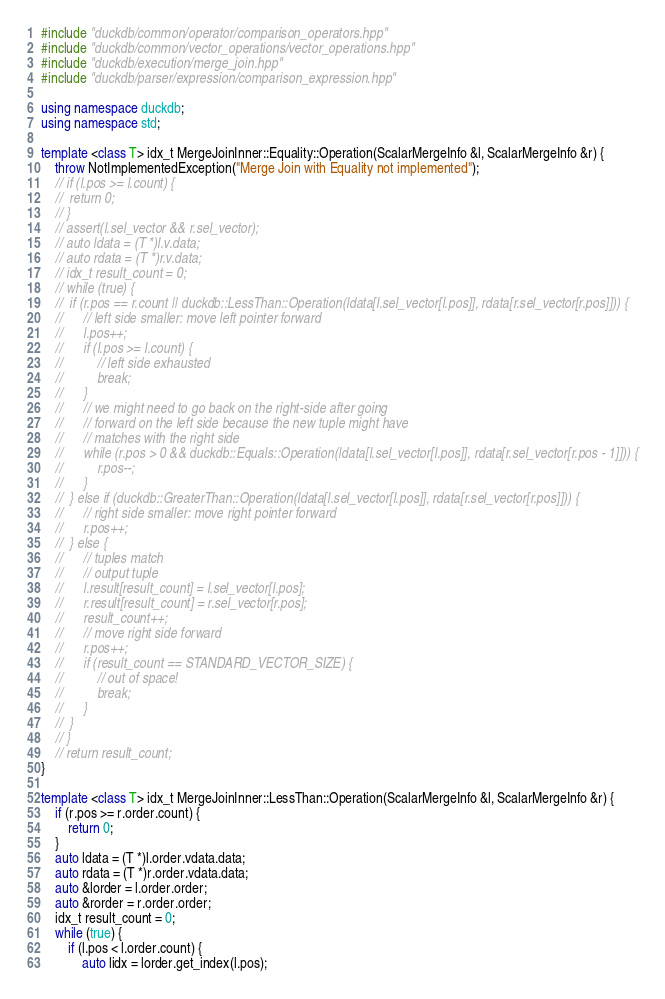Convert code to text. <code><loc_0><loc_0><loc_500><loc_500><_C++_>#include "duckdb/common/operator/comparison_operators.hpp"
#include "duckdb/common/vector_operations/vector_operations.hpp"
#include "duckdb/execution/merge_join.hpp"
#include "duckdb/parser/expression/comparison_expression.hpp"

using namespace duckdb;
using namespace std;

template <class T> idx_t MergeJoinInner::Equality::Operation(ScalarMergeInfo &l, ScalarMergeInfo &r) {
	throw NotImplementedException("Merge Join with Equality not implemented");
	// if (l.pos >= l.count) {
	// 	return 0;
	// }
	// assert(l.sel_vector && r.sel_vector);
	// auto ldata = (T *)l.v.data;
	// auto rdata = (T *)r.v.data;
	// idx_t result_count = 0;
	// while (true) {
	// 	if (r.pos == r.count || duckdb::LessThan::Operation(ldata[l.sel_vector[l.pos]], rdata[r.sel_vector[r.pos]])) {
	// 		// left side smaller: move left pointer forward
	// 		l.pos++;
	// 		if (l.pos >= l.count) {
	// 			// left side exhausted
	// 			break;
	// 		}
	// 		// we might need to go back on the right-side after going
	// 		// forward on the left side because the new tuple might have
	// 		// matches with the right side
	// 		while (r.pos > 0 && duckdb::Equals::Operation(ldata[l.sel_vector[l.pos]], rdata[r.sel_vector[r.pos - 1]])) {
	// 			r.pos--;
	// 		}
	// 	} else if (duckdb::GreaterThan::Operation(ldata[l.sel_vector[l.pos]], rdata[r.sel_vector[r.pos]])) {
	// 		// right side smaller: move right pointer forward
	// 		r.pos++;
	// 	} else {
	// 		// tuples match
	// 		// output tuple
	// 		l.result[result_count] = l.sel_vector[l.pos];
	// 		r.result[result_count] = r.sel_vector[r.pos];
	// 		result_count++;
	// 		// move right side forward
	// 		r.pos++;
	// 		if (result_count == STANDARD_VECTOR_SIZE) {
	// 			// out of space!
	// 			break;
	// 		}
	// 	}
	// }
	// return result_count;
}

template <class T> idx_t MergeJoinInner::LessThan::Operation(ScalarMergeInfo &l, ScalarMergeInfo &r) {
	if (r.pos >= r.order.count) {
		return 0;
	}
	auto ldata = (T *)l.order.vdata.data;
	auto rdata = (T *)r.order.vdata.data;
	auto &lorder = l.order.order;
	auto &rorder = r.order.order;
	idx_t result_count = 0;
	while (true) {
		if (l.pos < l.order.count) {
			auto lidx = lorder.get_index(l.pos);</code> 